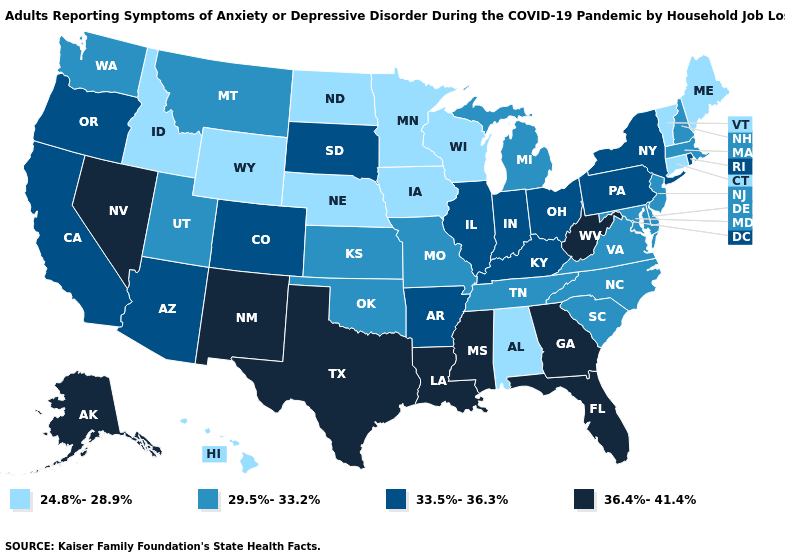What is the value of Texas?
Write a very short answer. 36.4%-41.4%. Does Washington have a higher value than Vermont?
Keep it brief. Yes. Name the states that have a value in the range 33.5%-36.3%?
Short answer required. Arizona, Arkansas, California, Colorado, Illinois, Indiana, Kentucky, New York, Ohio, Oregon, Pennsylvania, Rhode Island, South Dakota. Does Mississippi have the highest value in the South?
Concise answer only. Yes. Among the states that border Pennsylvania , which have the highest value?
Concise answer only. West Virginia. Does the map have missing data?
Quick response, please. No. What is the value of Oklahoma?
Short answer required. 29.5%-33.2%. What is the value of Arkansas?
Short answer required. 33.5%-36.3%. What is the highest value in states that border Oregon?
Give a very brief answer. 36.4%-41.4%. Which states have the lowest value in the South?
Quick response, please. Alabama. Does Minnesota have the lowest value in the USA?
Answer briefly. Yes. How many symbols are there in the legend?
Give a very brief answer. 4. What is the value of Alaska?
Write a very short answer. 36.4%-41.4%. Name the states that have a value in the range 36.4%-41.4%?
Quick response, please. Alaska, Florida, Georgia, Louisiana, Mississippi, Nevada, New Mexico, Texas, West Virginia. Which states have the lowest value in the West?
Quick response, please. Hawaii, Idaho, Wyoming. 